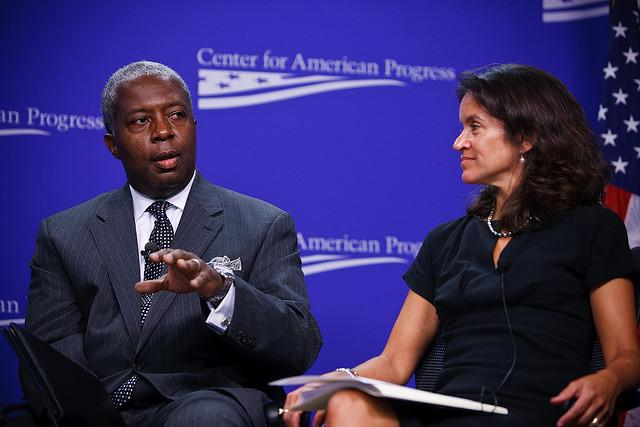What type talk is being given here? Please explain your reasoning. panel. This is a political debate. there is "center for american progress" on the wall. 